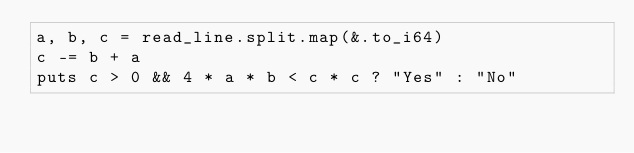<code> <loc_0><loc_0><loc_500><loc_500><_Crystal_>a, b, c = read_line.split.map(&.to_i64)
c -= b + a
puts c > 0 && 4 * a * b < c * c ? "Yes" : "No"
</code> 